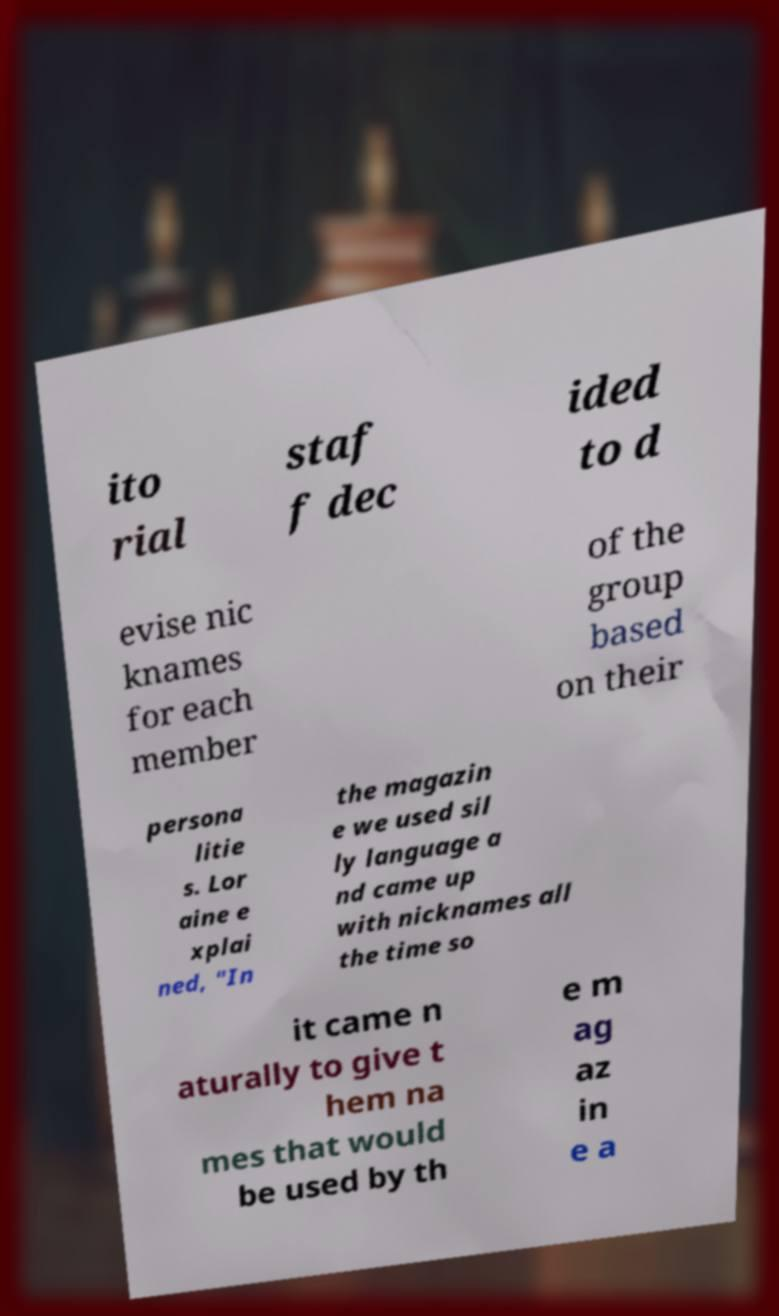Can you read and provide the text displayed in the image?This photo seems to have some interesting text. Can you extract and type it out for me? ito rial staf f dec ided to d evise nic knames for each member of the group based on their persona litie s. Lor aine e xplai ned, "In the magazin e we used sil ly language a nd came up with nicknames all the time so it came n aturally to give t hem na mes that would be used by th e m ag az in e a 